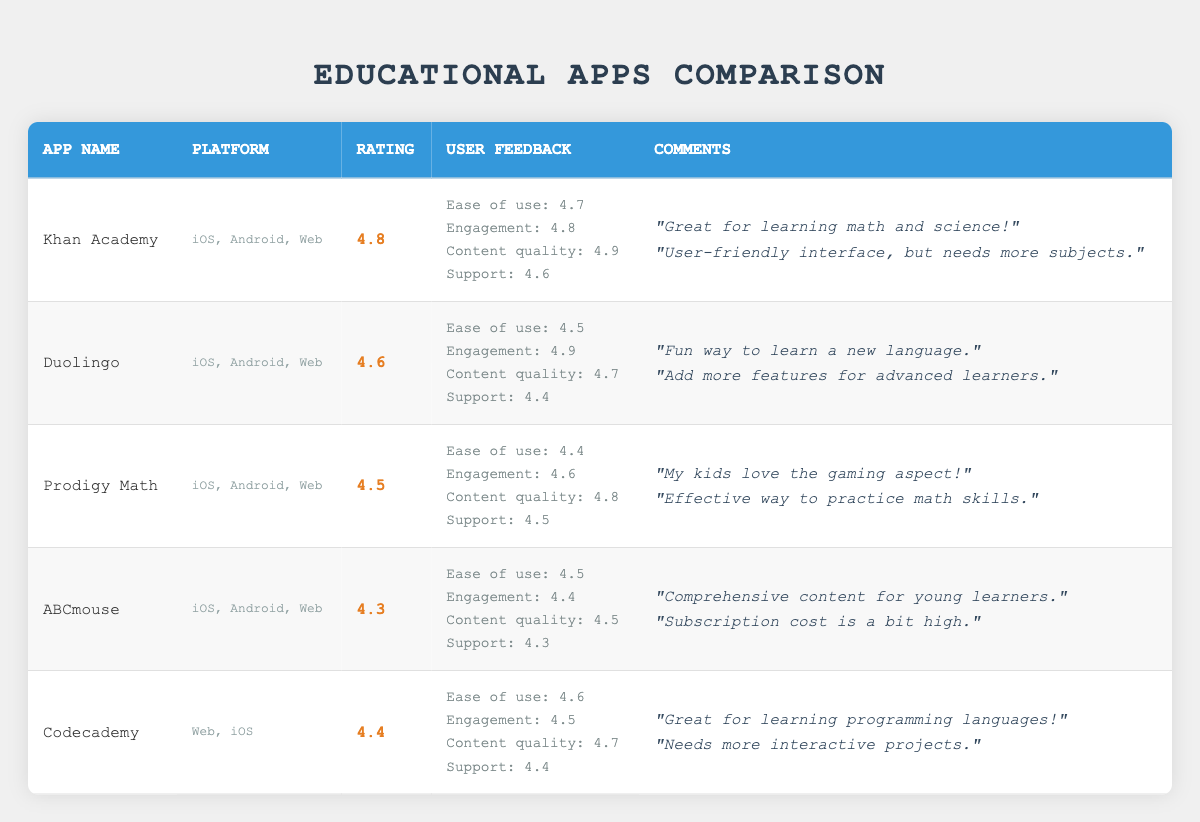What is the highest rated educational app? The highest rating among the apps listed is 4.8. The app that has this rating is Khan Academy.
Answer: Khan Academy Which app has the lowest rating? The lowest rating in the table is 4.3, which corresponds to the app ABCmouse.
Answer: ABCmouse True or False: Duolingo has a support score higher than 4.6. The support score for Duolingo is 4.4, which is less than 4.6. Therefore, this statement is false.
Answer: False What is the average ease of use rating across all apps? The ease of use ratings are 4.7, 4.5, 4.4, 4.5, and 4.6. To find the average: (4.7 + 4.5 + 4.4 + 4.5 + 4.6) = 22.7, and the average is 22.7/5 = 4.54.
Answer: 4.54 Which app has the highest content quality rating and what is that rating? The content quality ratings for the apps are 4.9 (Khan Academy), 4.7 (Duolingo), 4.8 (Prodigy Math), 4.5 (ABCmouse), and 4.7 (Codecademy). The highest rating of 4.9 belongs to Khan Academy.
Answer: Khan Academy, 4.9 How many platforms are represented by Prodigy Math? Prodigy Math is listed under three platforms: iOS, Android, and Web. Thus, it represents three platforms.
Answer: Three True or False: Codecademy has an engagement score that is higher than Prodigy Math. The engagement score for Codecademy is 4.5 while Prodigy Math has an engagement score of 4.6. Therefore, this statement is false.
Answer: False Which educational app is specifically known for programming languages? The educational app specifically known for programming languages is Codecademy.
Answer: Codecademy What is the difference in engagement scores between Khan Academy and ABCmouse? Khan Academy's engagement score is 4.8 and ABCmouse's is 4.4. The difference is 4.8 - 4.4 = 0.4.
Answer: 0.4 